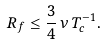Convert formula to latex. <formula><loc_0><loc_0><loc_500><loc_500>R _ { f } \leq \frac { 3 } { 4 } \, \nu \, T _ { c } ^ { - 1 } .</formula> 